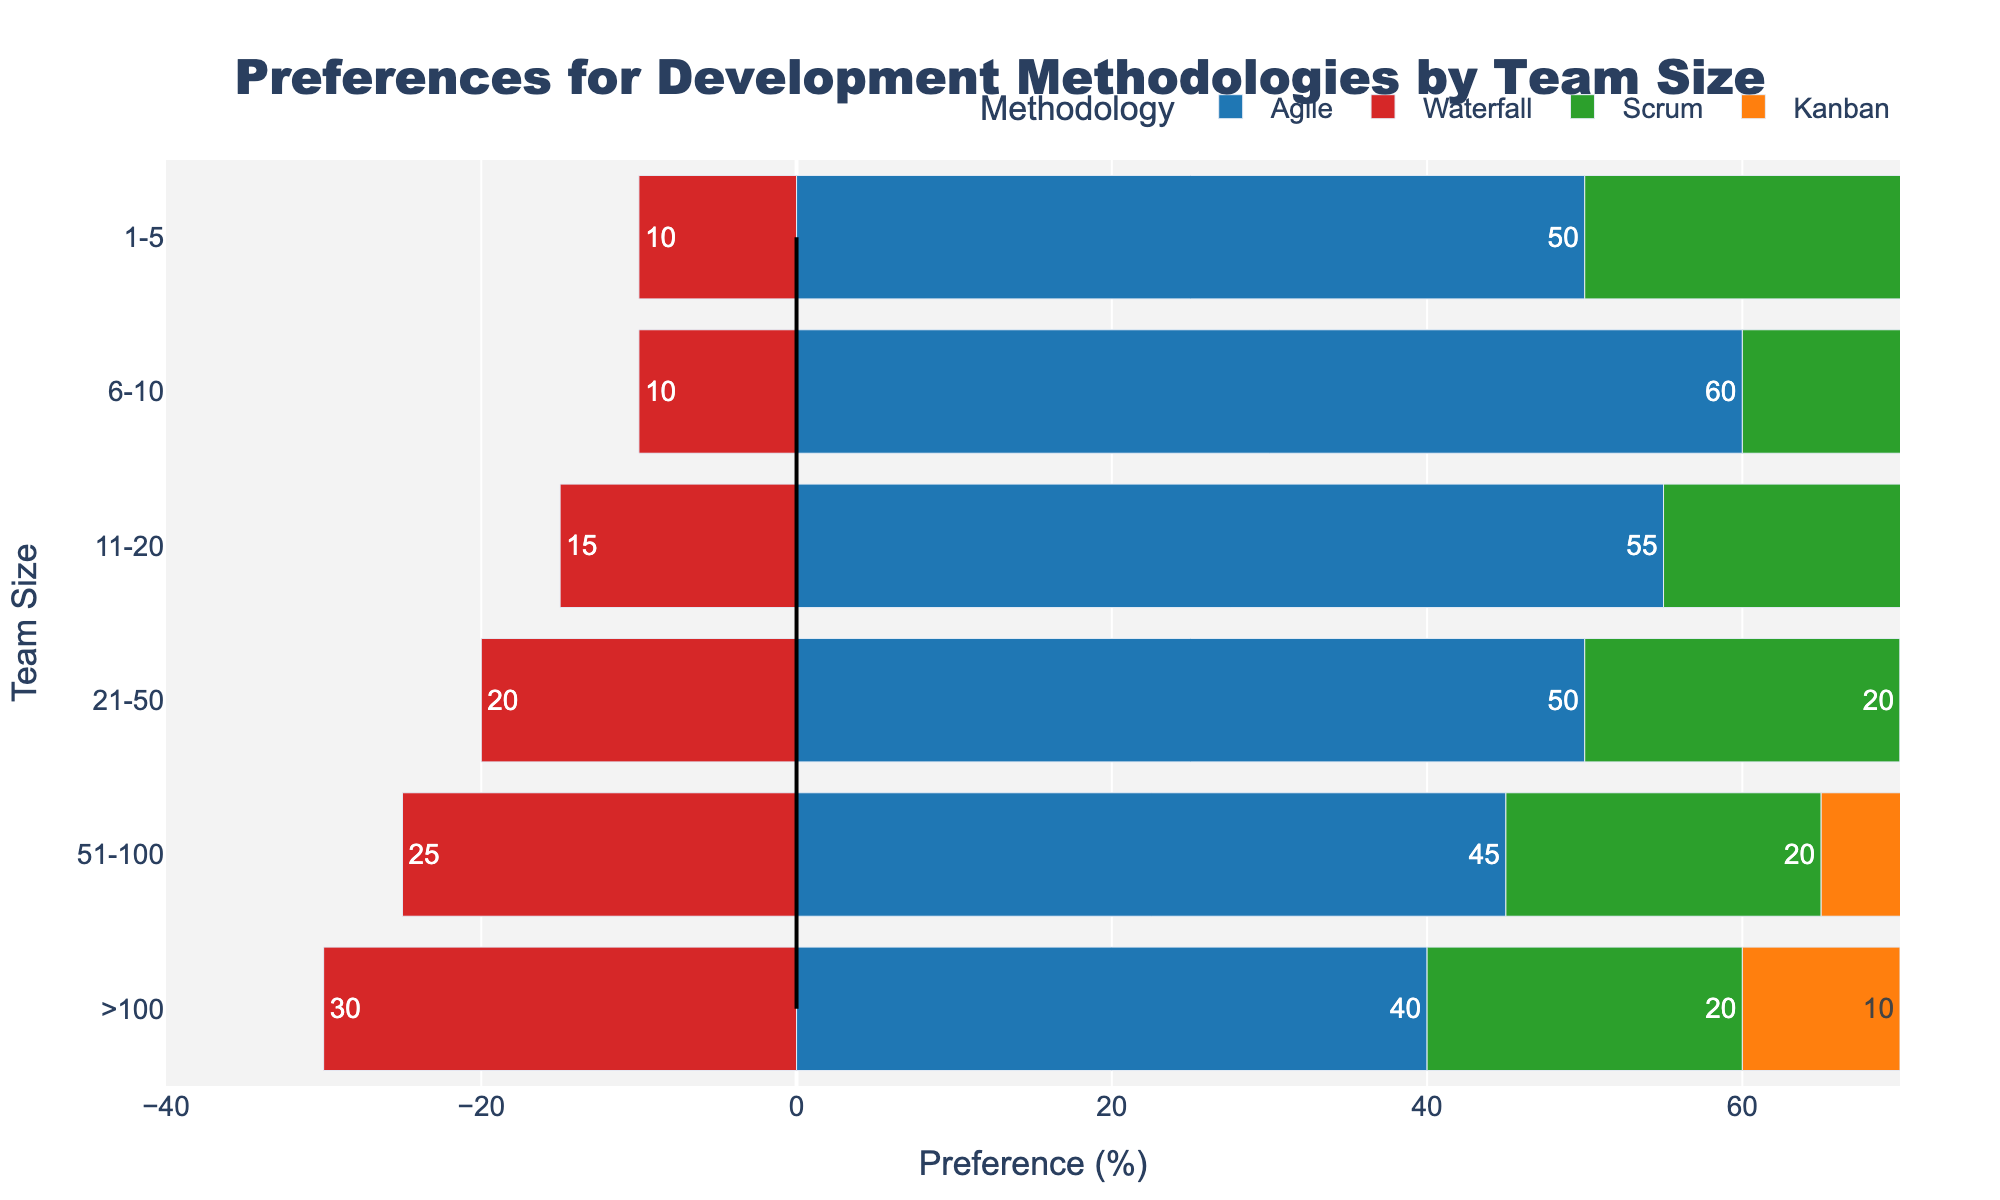What is the most preferred development methodology for team sizes of 6-10 members? The bar segment for Agile is the longest for the team size of 6-10 members, indicating it is the most preferred methodology in this group.
Answer: Agile Which team size has the highest preference for the Waterfall methodology? The preferred percentage is highest for the Waterfall methodology in the group with more than 100 members as indicated by the larger red bar in this group.
Answer: >100 How does the preference for the Scrum methodology change as team size increases from 1-5 to >100? The preference for the Scrum methodology remains consistent at 20% from the team size of 6-10 to >100, but it is higher at 30% in the smallest team size of 1-5.
Answer: It decreases initially, then remains constant What is the combined preference percentage for Agile and Scrum for the team size of 11-20? The Agile preference is 55% and the Scrum preference is 20%. Adding these gives a combined preference of 75%.
Answer: 75% For team sizes greater than 100, which methodology is least preferred? For the group with more than 100 members, the smallest bar is the orange one representing Kanban, which stands at 10%.
Answer: Kanban Compare the preference for the Waterfall methodology between team sizes of 1-5 and 51-100. For team sizes of 1-5, the preference for Waterfall is 10%, whereas for team sizes of 51-100, it is 25%.
Answer: 51-100 has higher preference Which team size shows the least variability in preferences across the four methodologies? The team size of more than 100 shows the least variability since the preferences for Agile, Waterfall, Scrum, and Kanban are relatively close to each other compared to other groups.
Answer: >100 Calculate the average preference for Kanban across all team sizes. The preference percentages for Kanban across team sizes are all 10%. The average of 10% across all groups is 10%.
Answer: 10% How does the preference for Agile change from the smallest to the largest team size? Agile preference decreases from 50% in the smallest team size (1-5) to 40% in the largest team size (>100).
Answer: It decreases 